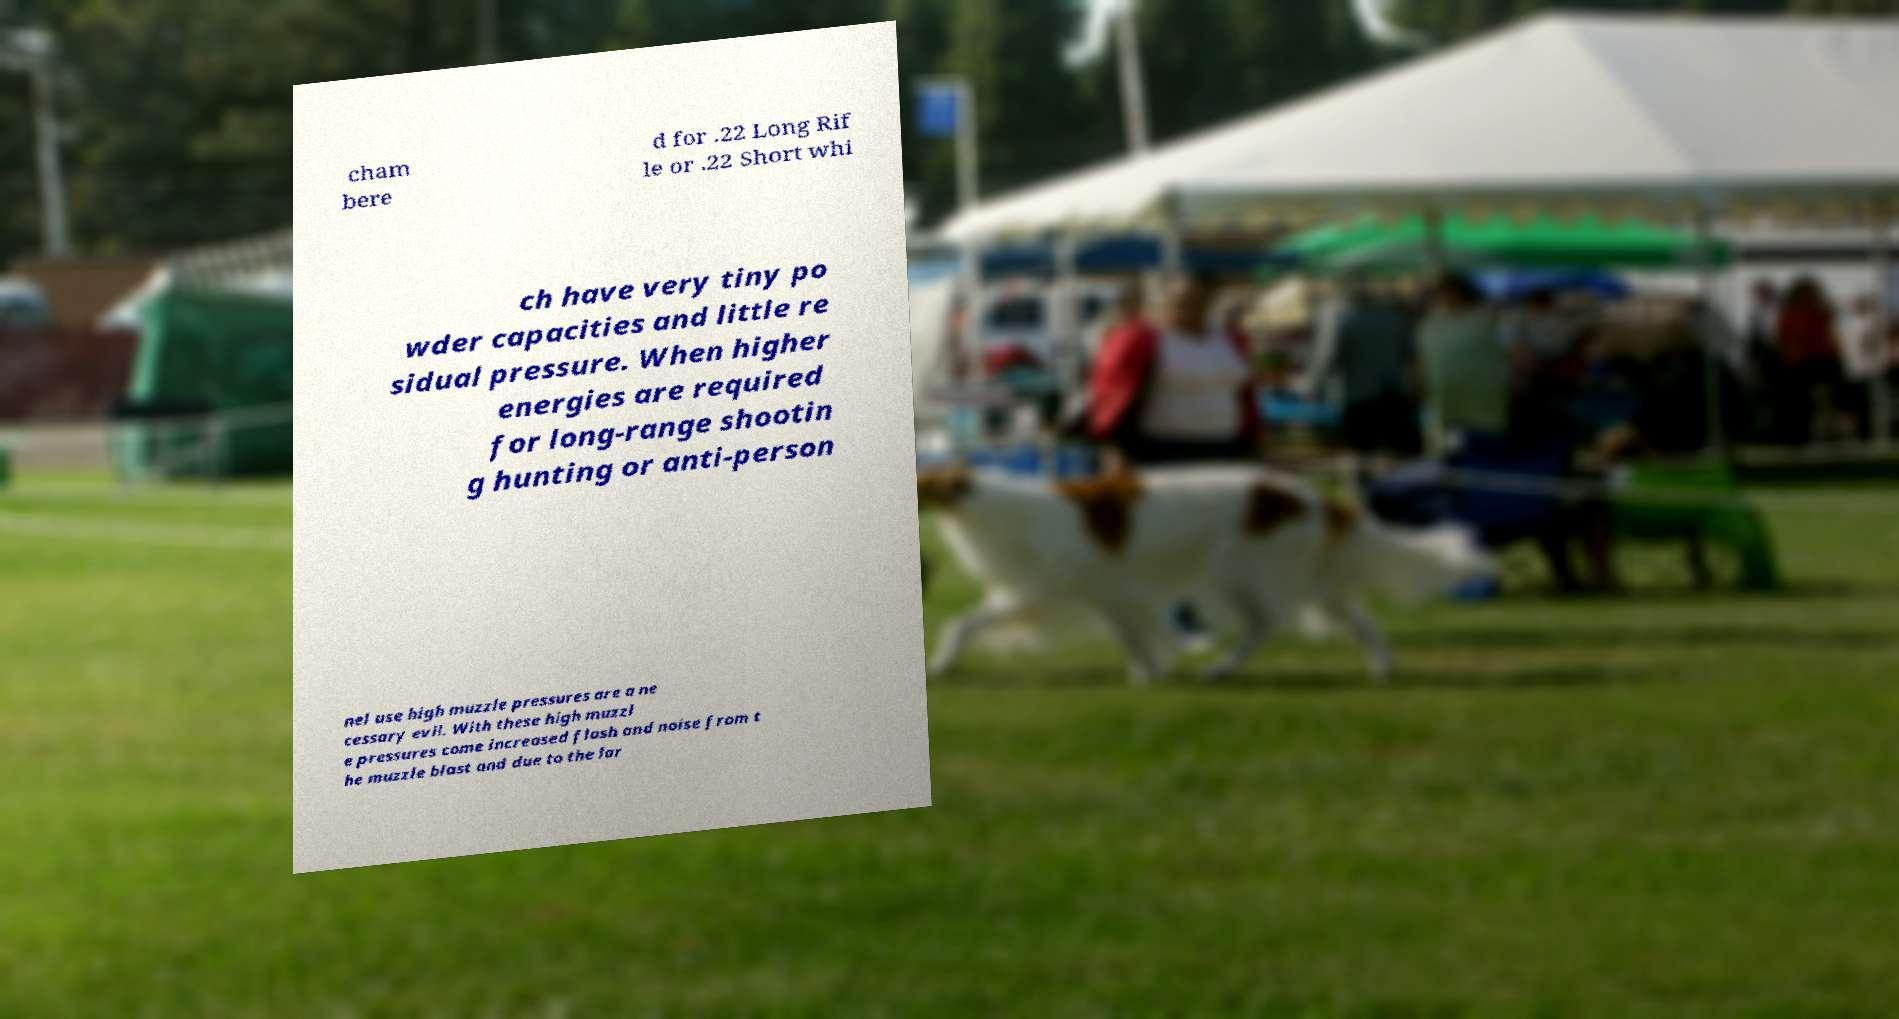For documentation purposes, I need the text within this image transcribed. Could you provide that? cham bere d for .22 Long Rif le or .22 Short whi ch have very tiny po wder capacities and little re sidual pressure. When higher energies are required for long-range shootin g hunting or anti-person nel use high muzzle pressures are a ne cessary evil. With these high muzzl e pressures come increased flash and noise from t he muzzle blast and due to the lar 